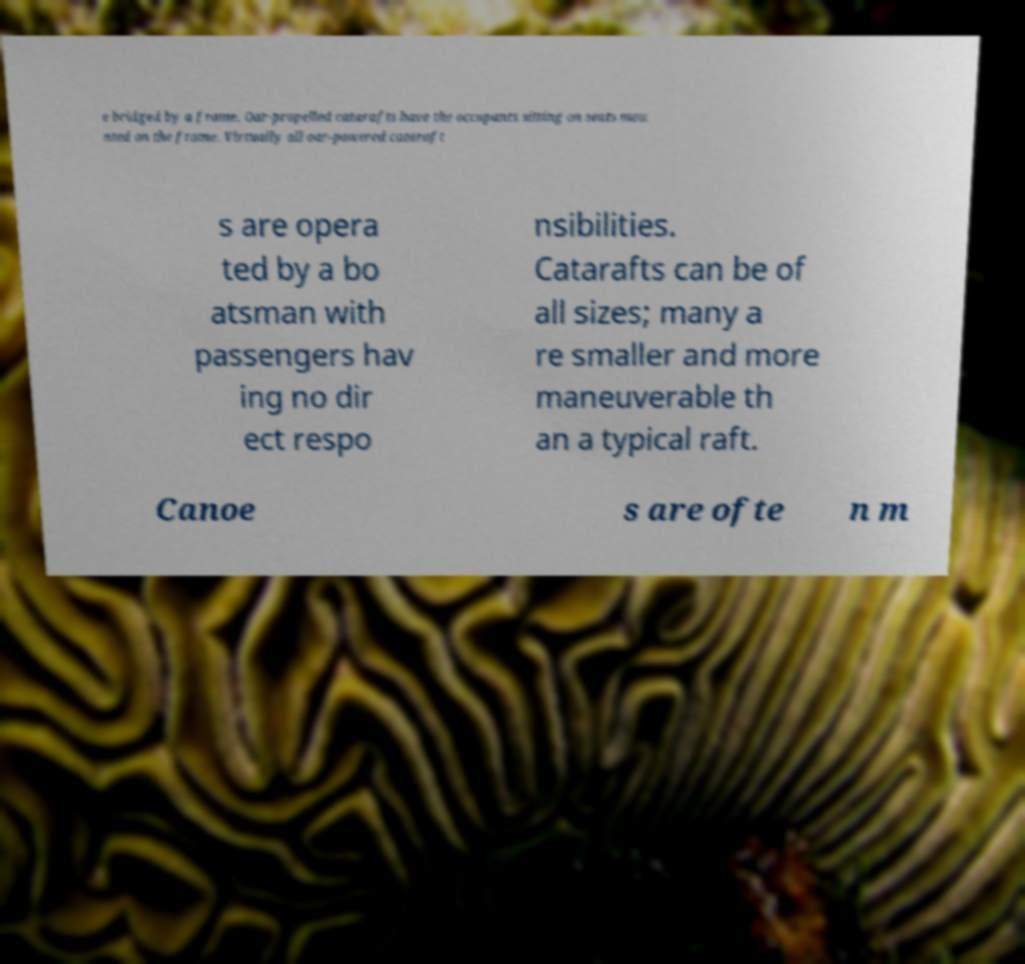Could you assist in decoding the text presented in this image and type it out clearly? e bridged by a frame. Oar-propelled catarafts have the occupants sitting on seats mou nted on the frame. Virtually all oar-powered cataraft s are opera ted by a bo atsman with passengers hav ing no dir ect respo nsibilities. Catarafts can be of all sizes; many a re smaller and more maneuverable th an a typical raft. Canoe s are ofte n m 